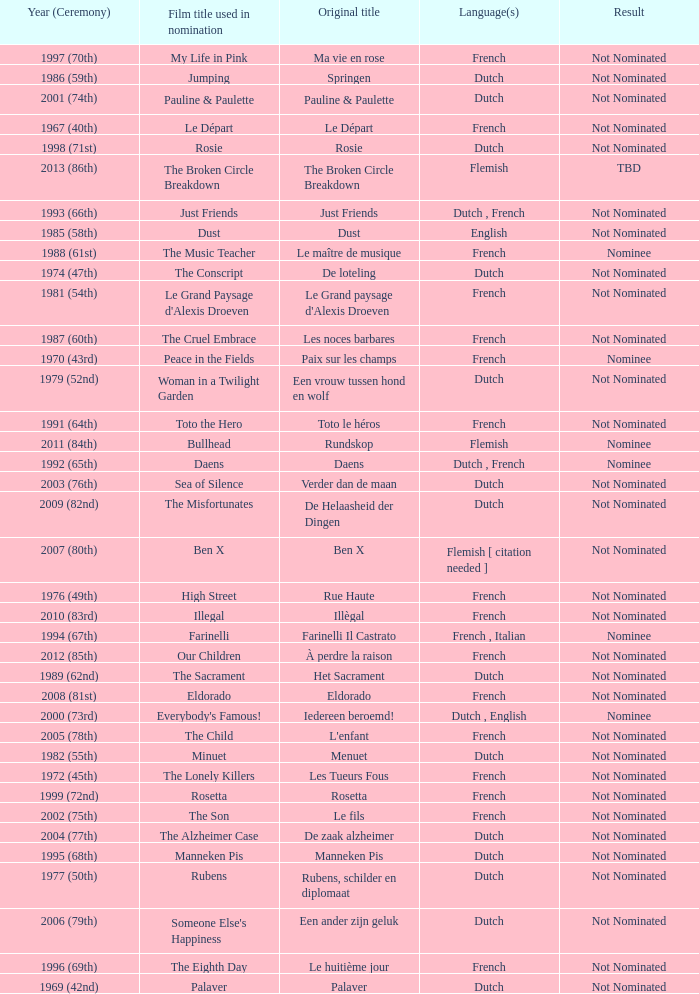What was the title used for Rosie, the film nominated for the dutch language? Rosie. 